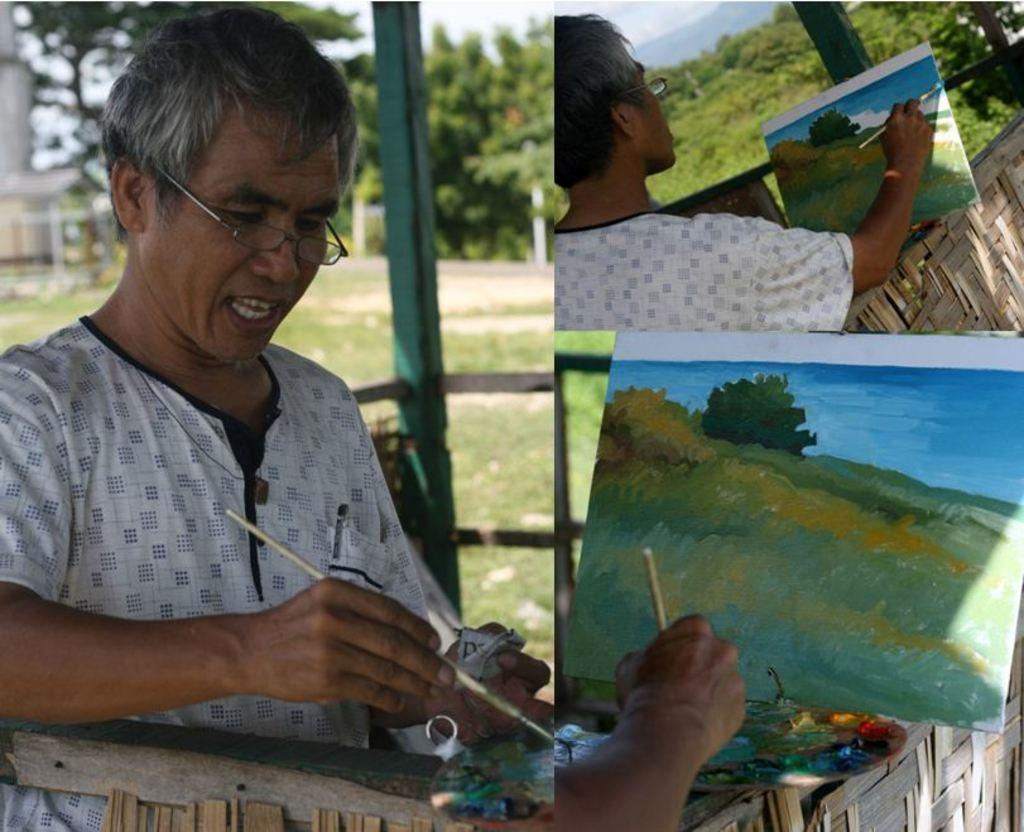How many people are present in the image? There are two persons in the image. What are the persons doing in the image? The persons are painting on a paper. What tools are they using for painting? They are using brushes for painting. What can be seen in the background of the image? There are trees, a fence, and the sky visible in the background of the image. When was the image taken? The image was taken during the day. What type of ornament can be seen hanging from the fence in the image? There is no ornament hanging from the fence in the image. Can you tell me how many bikes are parked near the persons in the image? There are no bikes present in the image. 